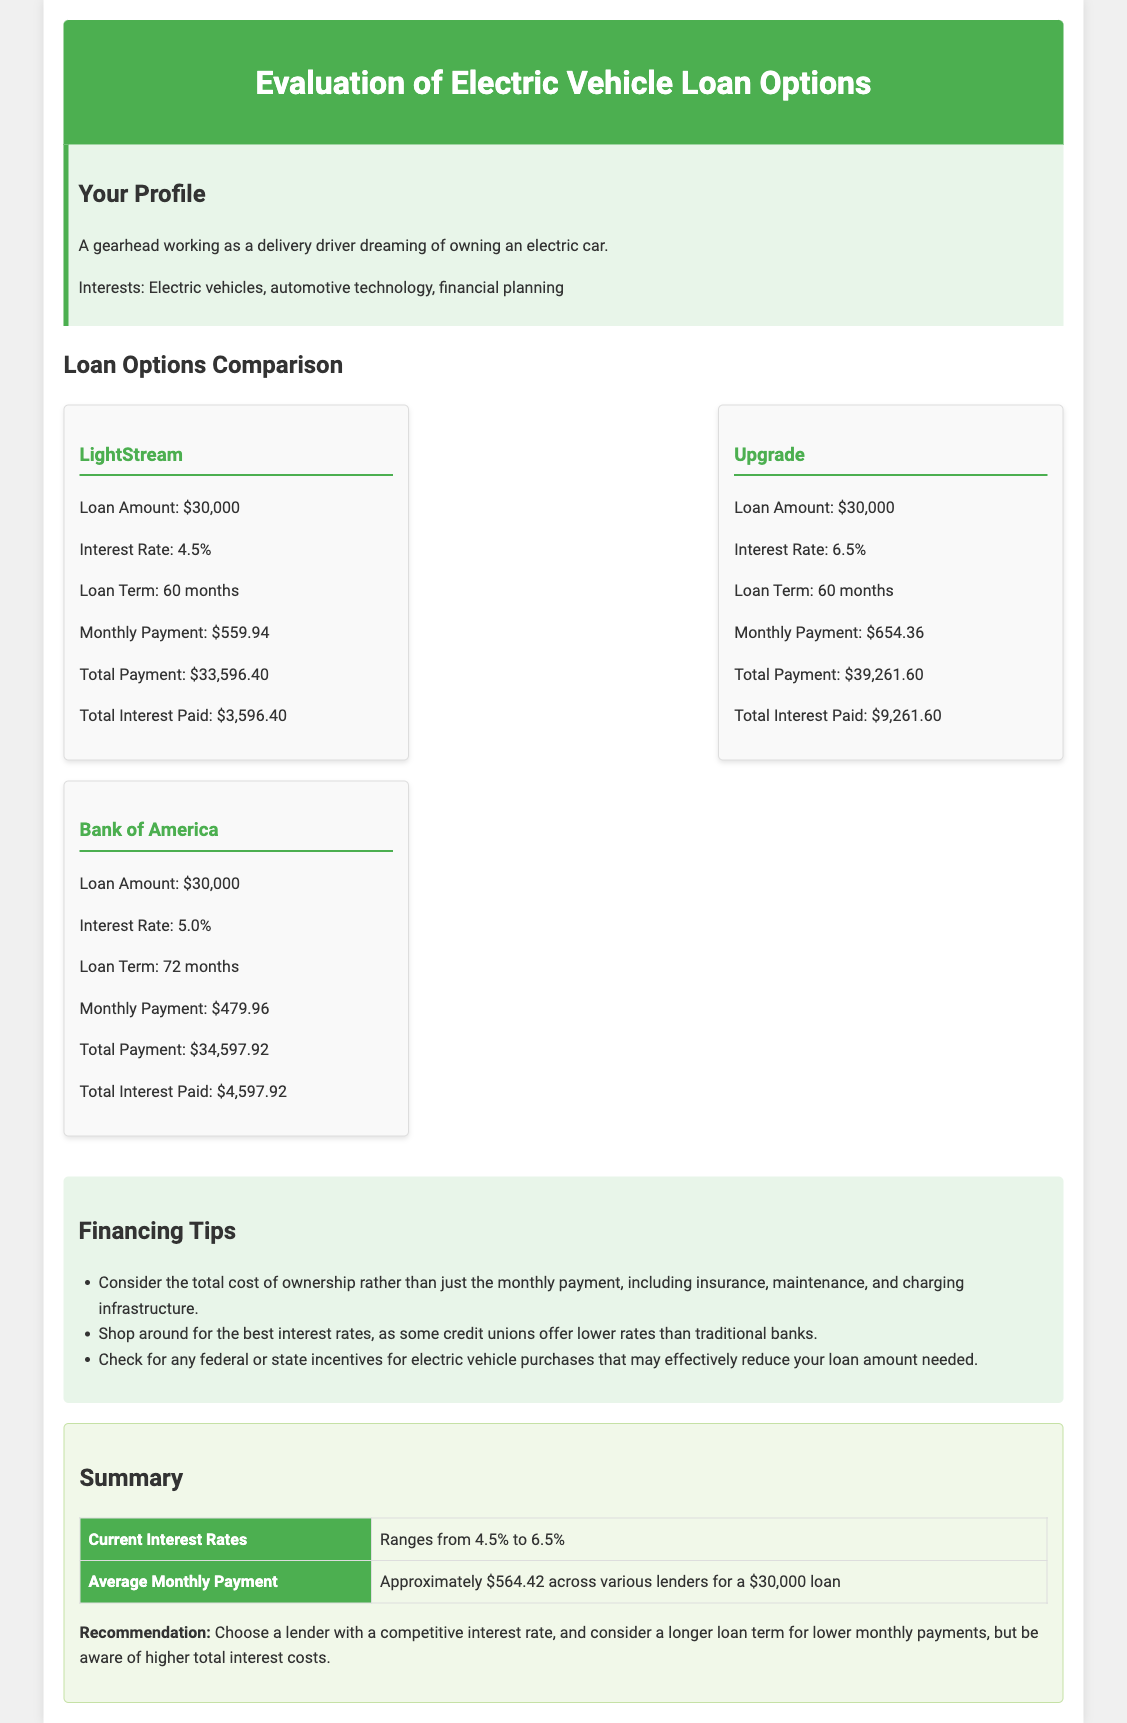What is the loan amount for LightStream? The loan amount listed for LightStream in the document is $30,000.
Answer: $30,000 What is the interest rate offered by Upgrade? The interest rate for Upgrade is stated as 6.5%.
Answer: 6.5% What is the total payment for the Bank of America loan? The total payment for the Bank of America loan is calculated as $34,597.92.
Answer: $34,597.92 Which lender has the lowest monthly payment? The lender with the lowest monthly payment of $479.96 is Bank of America.
Answer: Bank of America What is the average monthly payment across various lenders? The average monthly payment is approximately $564.42 across various lenders for a $30,000 loan.
Answer: Approximately $564.42 What is the total interest paid for LightStream? The total interest paid for LightStream is given as $3,596.40.
Answer: $3,596.40 What is a recommended action according to the summary? The recommendation suggests choosing a lender with a competitive interest rate.
Answer: Choose a lender with a competitive interest rate What are the available loan terms for the loans listed? The loan terms available include 60 months and 72 months.
Answer: 60 months and 72 months What is a financing tip mentioned in the document? One financing tip mentioned is to shop around for the best interest rates.
Answer: Shop around for the best interest rates 